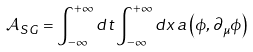Convert formula to latex. <formula><loc_0><loc_0><loc_500><loc_500>\mathcal { A } _ { S G } = \int _ { - \infty } ^ { + \infty } d t \int _ { - \infty } ^ { + \infty } d x \, a \left ( \phi , \partial _ { \mu } \phi \right )</formula> 